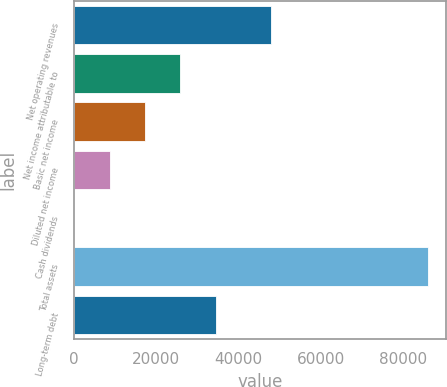Convert chart. <chart><loc_0><loc_0><loc_500><loc_500><bar_chart><fcel>Net operating revenues<fcel>Net income attributable to<fcel>Basic net income<fcel>Diluted net income<fcel>Cash dividends<fcel>Total assets<fcel>Long-term debt<nl><fcel>48017<fcel>25852.9<fcel>17235.6<fcel>8618.32<fcel>1.02<fcel>86174<fcel>34470.2<nl></chart> 